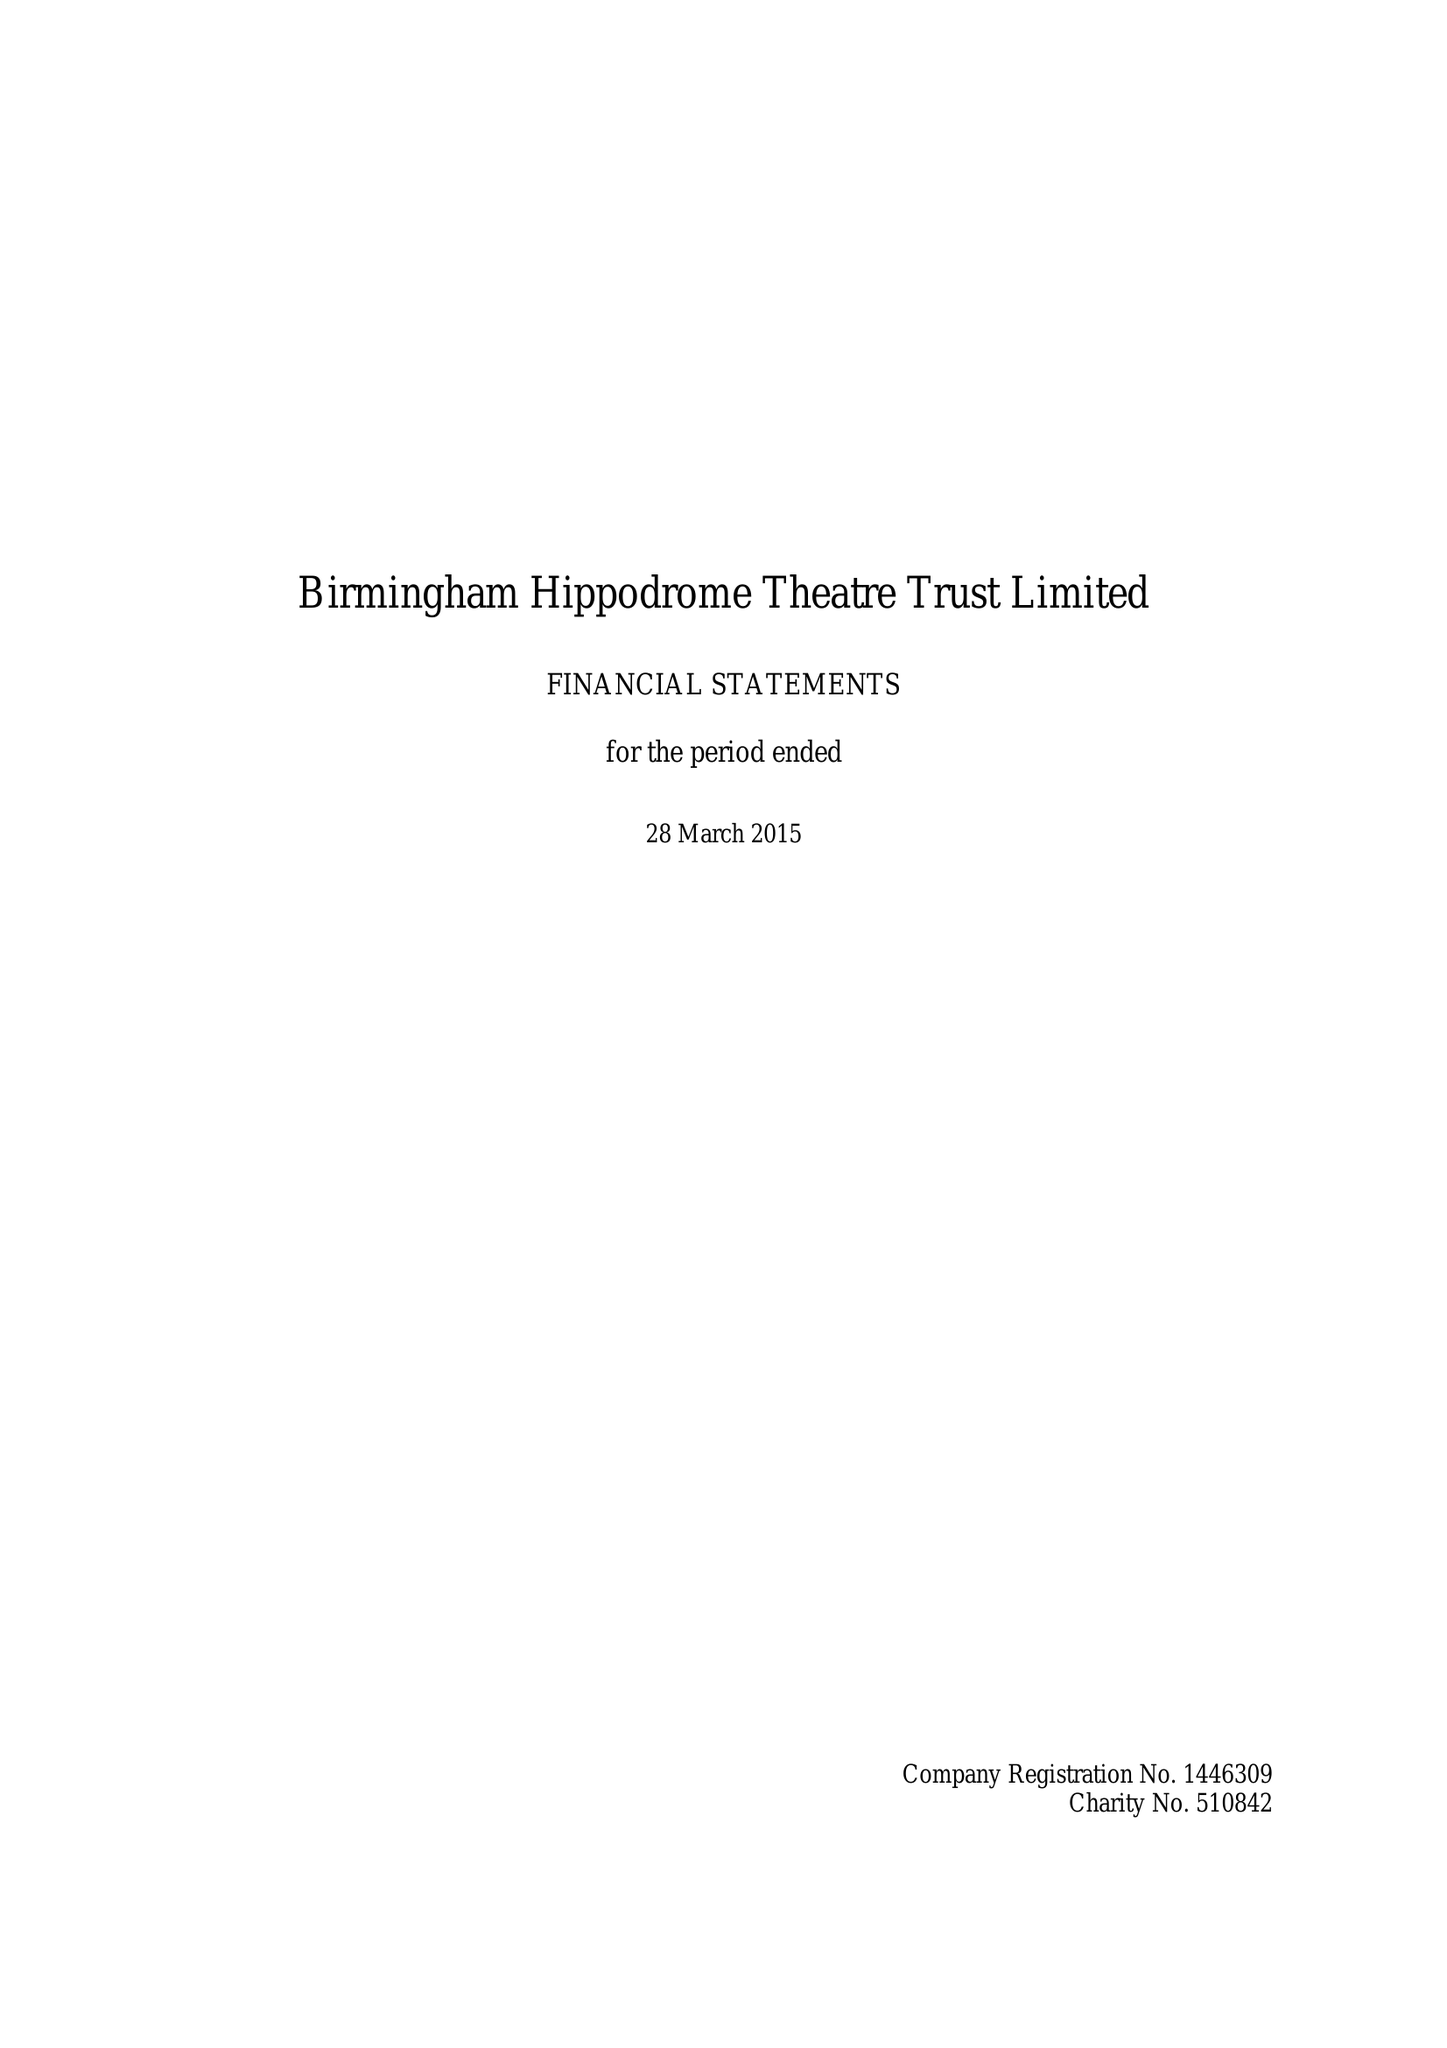What is the value for the address__post_town?
Answer the question using a single word or phrase. BIRMINGHAM 